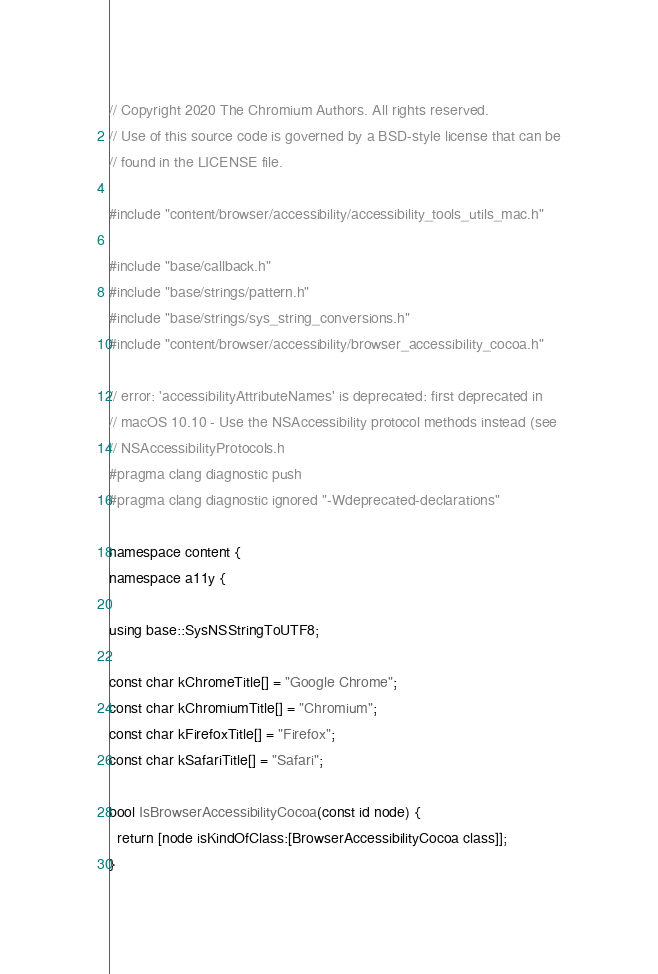Convert code to text. <code><loc_0><loc_0><loc_500><loc_500><_ObjectiveC_>// Copyright 2020 The Chromium Authors. All rights reserved.
// Use of this source code is governed by a BSD-style license that can be
// found in the LICENSE file.

#include "content/browser/accessibility/accessibility_tools_utils_mac.h"

#include "base/callback.h"
#include "base/strings/pattern.h"
#include "base/strings/sys_string_conversions.h"
#include "content/browser/accessibility/browser_accessibility_cocoa.h"

// error: 'accessibilityAttributeNames' is deprecated: first deprecated in
// macOS 10.10 - Use the NSAccessibility protocol methods instead (see
// NSAccessibilityProtocols.h
#pragma clang diagnostic push
#pragma clang diagnostic ignored "-Wdeprecated-declarations"

namespace content {
namespace a11y {

using base::SysNSStringToUTF8;

const char kChromeTitle[] = "Google Chrome";
const char kChromiumTitle[] = "Chromium";
const char kFirefoxTitle[] = "Firefox";
const char kSafariTitle[] = "Safari";

bool IsBrowserAccessibilityCocoa(const id node) {
  return [node isKindOfClass:[BrowserAccessibilityCocoa class]];
}
</code> 